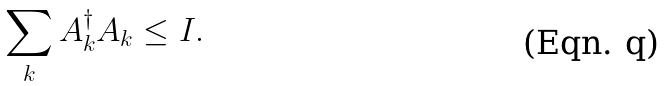Convert formula to latex. <formula><loc_0><loc_0><loc_500><loc_500>\sum _ { k } A ^ { \dagger } _ { k } A _ { k } \leq I .</formula> 